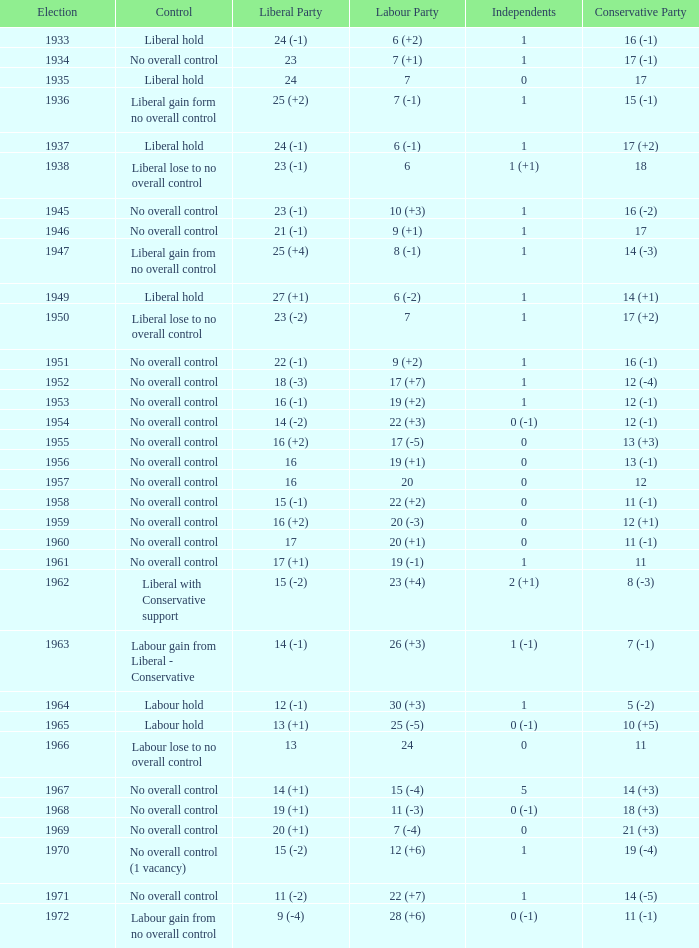What was the control for the year with a Conservative Party result of 10 (+5)? Labour hold. 